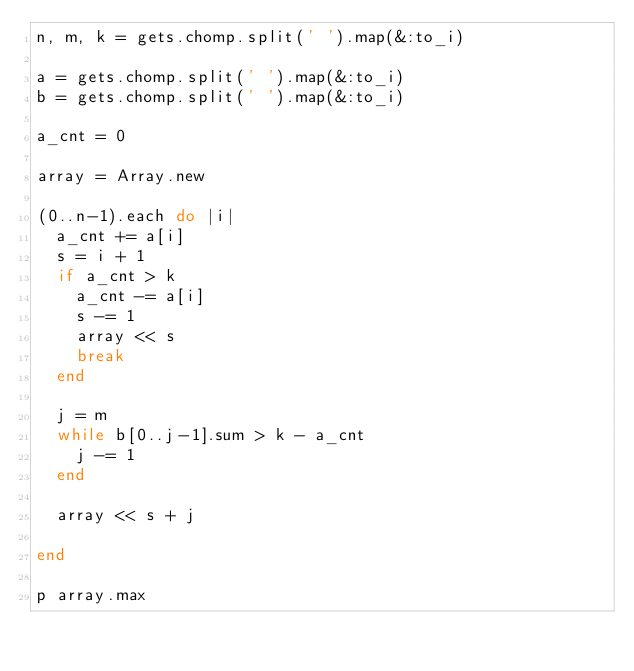<code> <loc_0><loc_0><loc_500><loc_500><_Ruby_>n, m, k = gets.chomp.split(' ').map(&:to_i)

a = gets.chomp.split(' ').map(&:to_i)
b = gets.chomp.split(' ').map(&:to_i)

a_cnt = 0

array = Array.new

(0..n-1).each do |i|
  a_cnt += a[i]
  s = i + 1
  if a_cnt > k
    a_cnt -= a[i]
    s -= 1
    array << s
    break
  end
  
  j = m
  while b[0..j-1].sum > k - a_cnt
    j -= 1 
  end

  array << s + j

end

p array.max</code> 